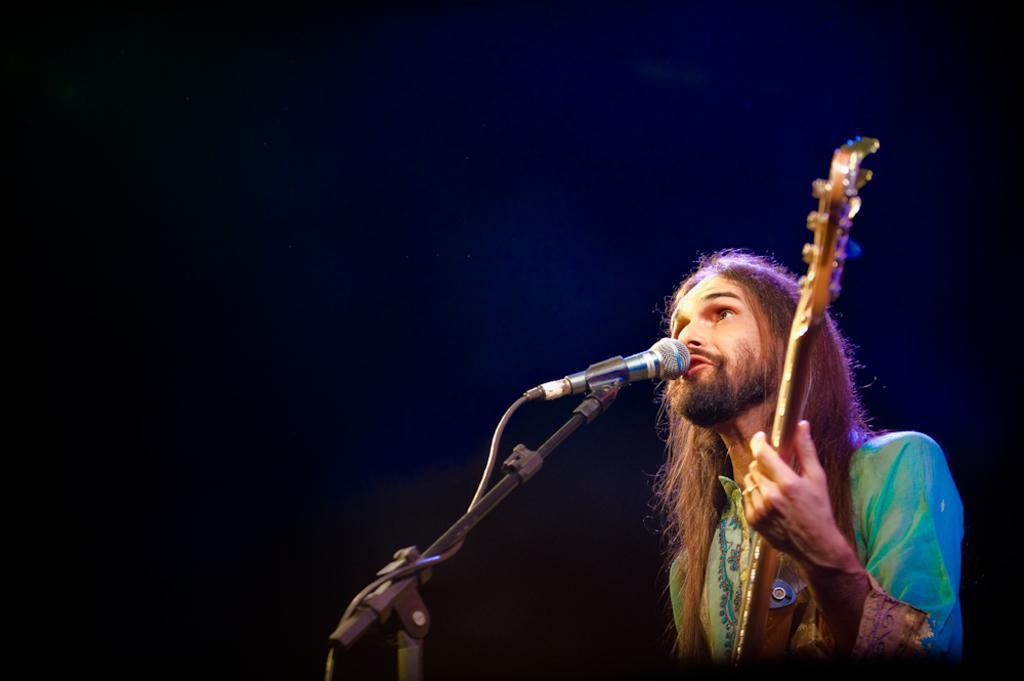Describe this image in one or two sentences. This picture is clicked in a musical concert. The man on the right corner of the picture wearing green shirt is holding a guitar in his hands. In front of him, we see a microphone and he is singing a song on the microphone. In the background, it is black in color. 